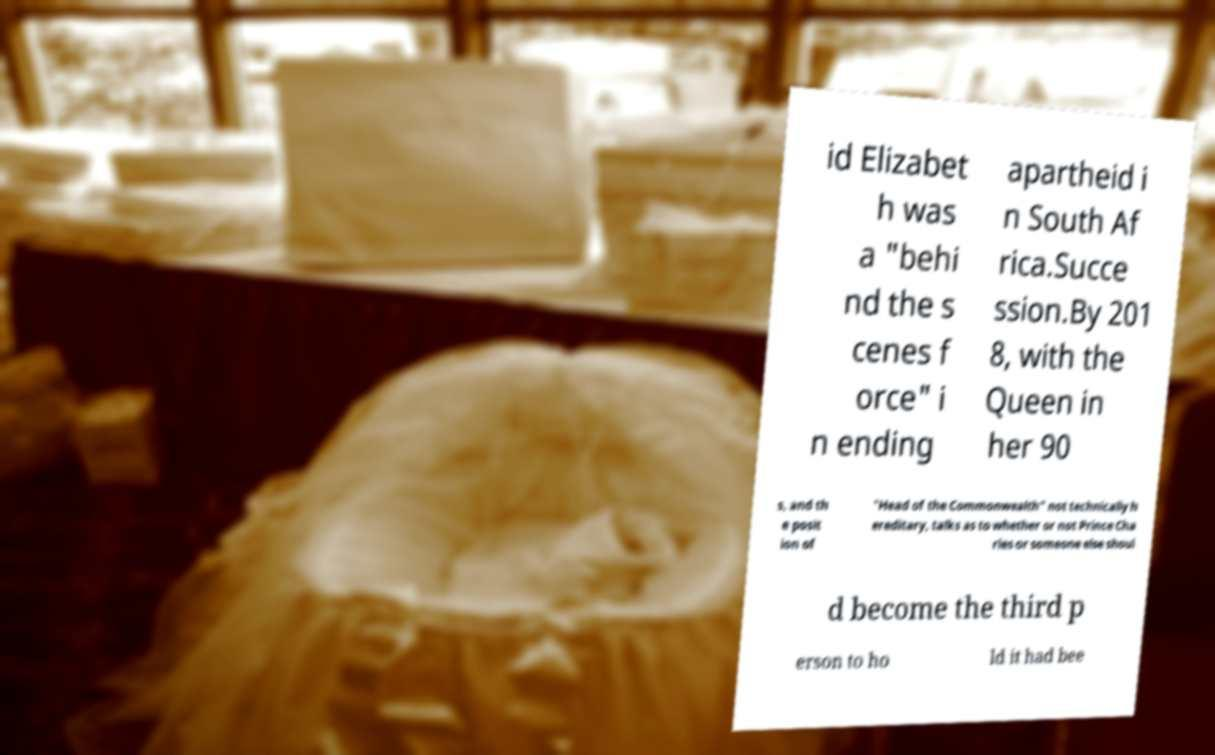Can you read and provide the text displayed in the image?This photo seems to have some interesting text. Can you extract and type it out for me? id Elizabet h was a "behi nd the s cenes f orce" i n ending apartheid i n South Af rica.Succe ssion.By 201 8, with the Queen in her 90 s, and th e posit ion of "Head of the Commonwealth" not technically h ereditary, talks as to whether or not Prince Cha rles or someone else shoul d become the third p erson to ho ld it had bee 